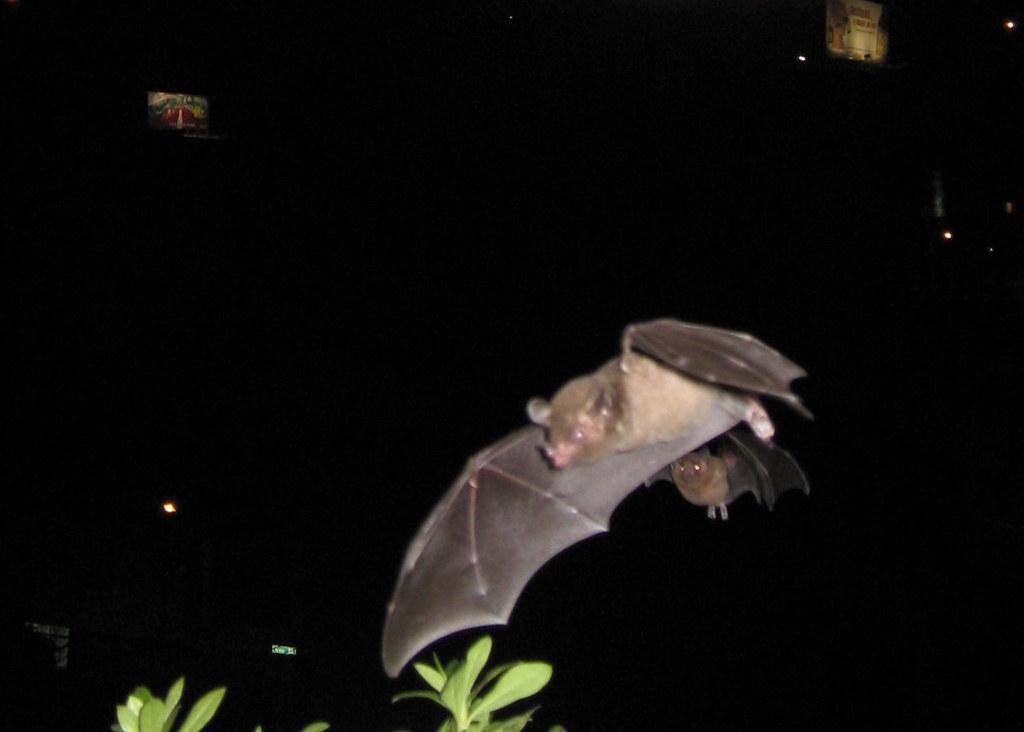In one or two sentences, can you explain what this image depicts? In this image, we can see a bat. There are leaves at the bottom of the image. 